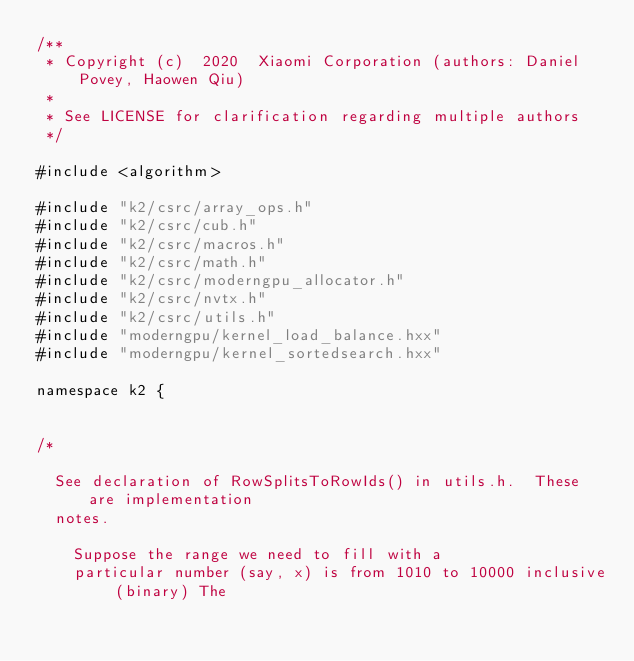<code> <loc_0><loc_0><loc_500><loc_500><_Cuda_>/**
 * Copyright (c)  2020  Xiaomi Corporation (authors: Daniel Povey, Haowen Qiu)
 *
 * See LICENSE for clarification regarding multiple authors
 */

#include <algorithm>

#include "k2/csrc/array_ops.h"
#include "k2/csrc/cub.h"
#include "k2/csrc/macros.h"
#include "k2/csrc/math.h"
#include "k2/csrc/moderngpu_allocator.h"
#include "k2/csrc/nvtx.h"
#include "k2/csrc/utils.h"
#include "moderngpu/kernel_load_balance.hxx"
#include "moderngpu/kernel_sortedsearch.hxx"

namespace k2 {


/*

  See declaration of RowSplitsToRowIds() in utils.h.  These are implementation
  notes.

    Suppose the range we need to fill with a
    particular number (say, x) is from 1010 to 10000 inclusive (binary) The</code> 